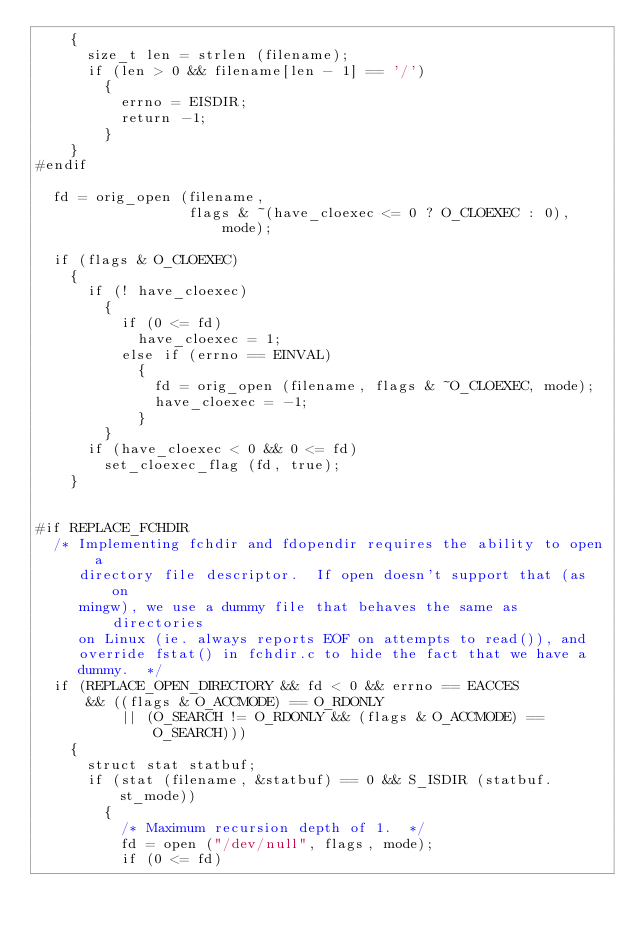Convert code to text. <code><loc_0><loc_0><loc_500><loc_500><_C_>    {
      size_t len = strlen (filename);
      if (len > 0 && filename[len - 1] == '/')
        {
          errno = EISDIR;
          return -1;
        }
    }
#endif

  fd = orig_open (filename,
                  flags & ~(have_cloexec <= 0 ? O_CLOEXEC : 0), mode);

  if (flags & O_CLOEXEC)
    {
      if (! have_cloexec)
        {
          if (0 <= fd)
            have_cloexec = 1;
          else if (errno == EINVAL)
            {
              fd = orig_open (filename, flags & ~O_CLOEXEC, mode);
              have_cloexec = -1;
            }
        }
      if (have_cloexec < 0 && 0 <= fd)
        set_cloexec_flag (fd, true);
    }


#if REPLACE_FCHDIR
  /* Implementing fchdir and fdopendir requires the ability to open a
     directory file descriptor.  If open doesn't support that (as on
     mingw), we use a dummy file that behaves the same as directories
     on Linux (ie. always reports EOF on attempts to read()), and
     override fstat() in fchdir.c to hide the fact that we have a
     dummy.  */
  if (REPLACE_OPEN_DIRECTORY && fd < 0 && errno == EACCES
      && ((flags & O_ACCMODE) == O_RDONLY
          || (O_SEARCH != O_RDONLY && (flags & O_ACCMODE) == O_SEARCH)))
    {
      struct stat statbuf;
      if (stat (filename, &statbuf) == 0 && S_ISDIR (statbuf.st_mode))
        {
          /* Maximum recursion depth of 1.  */
          fd = open ("/dev/null", flags, mode);
          if (0 <= fd)</code> 